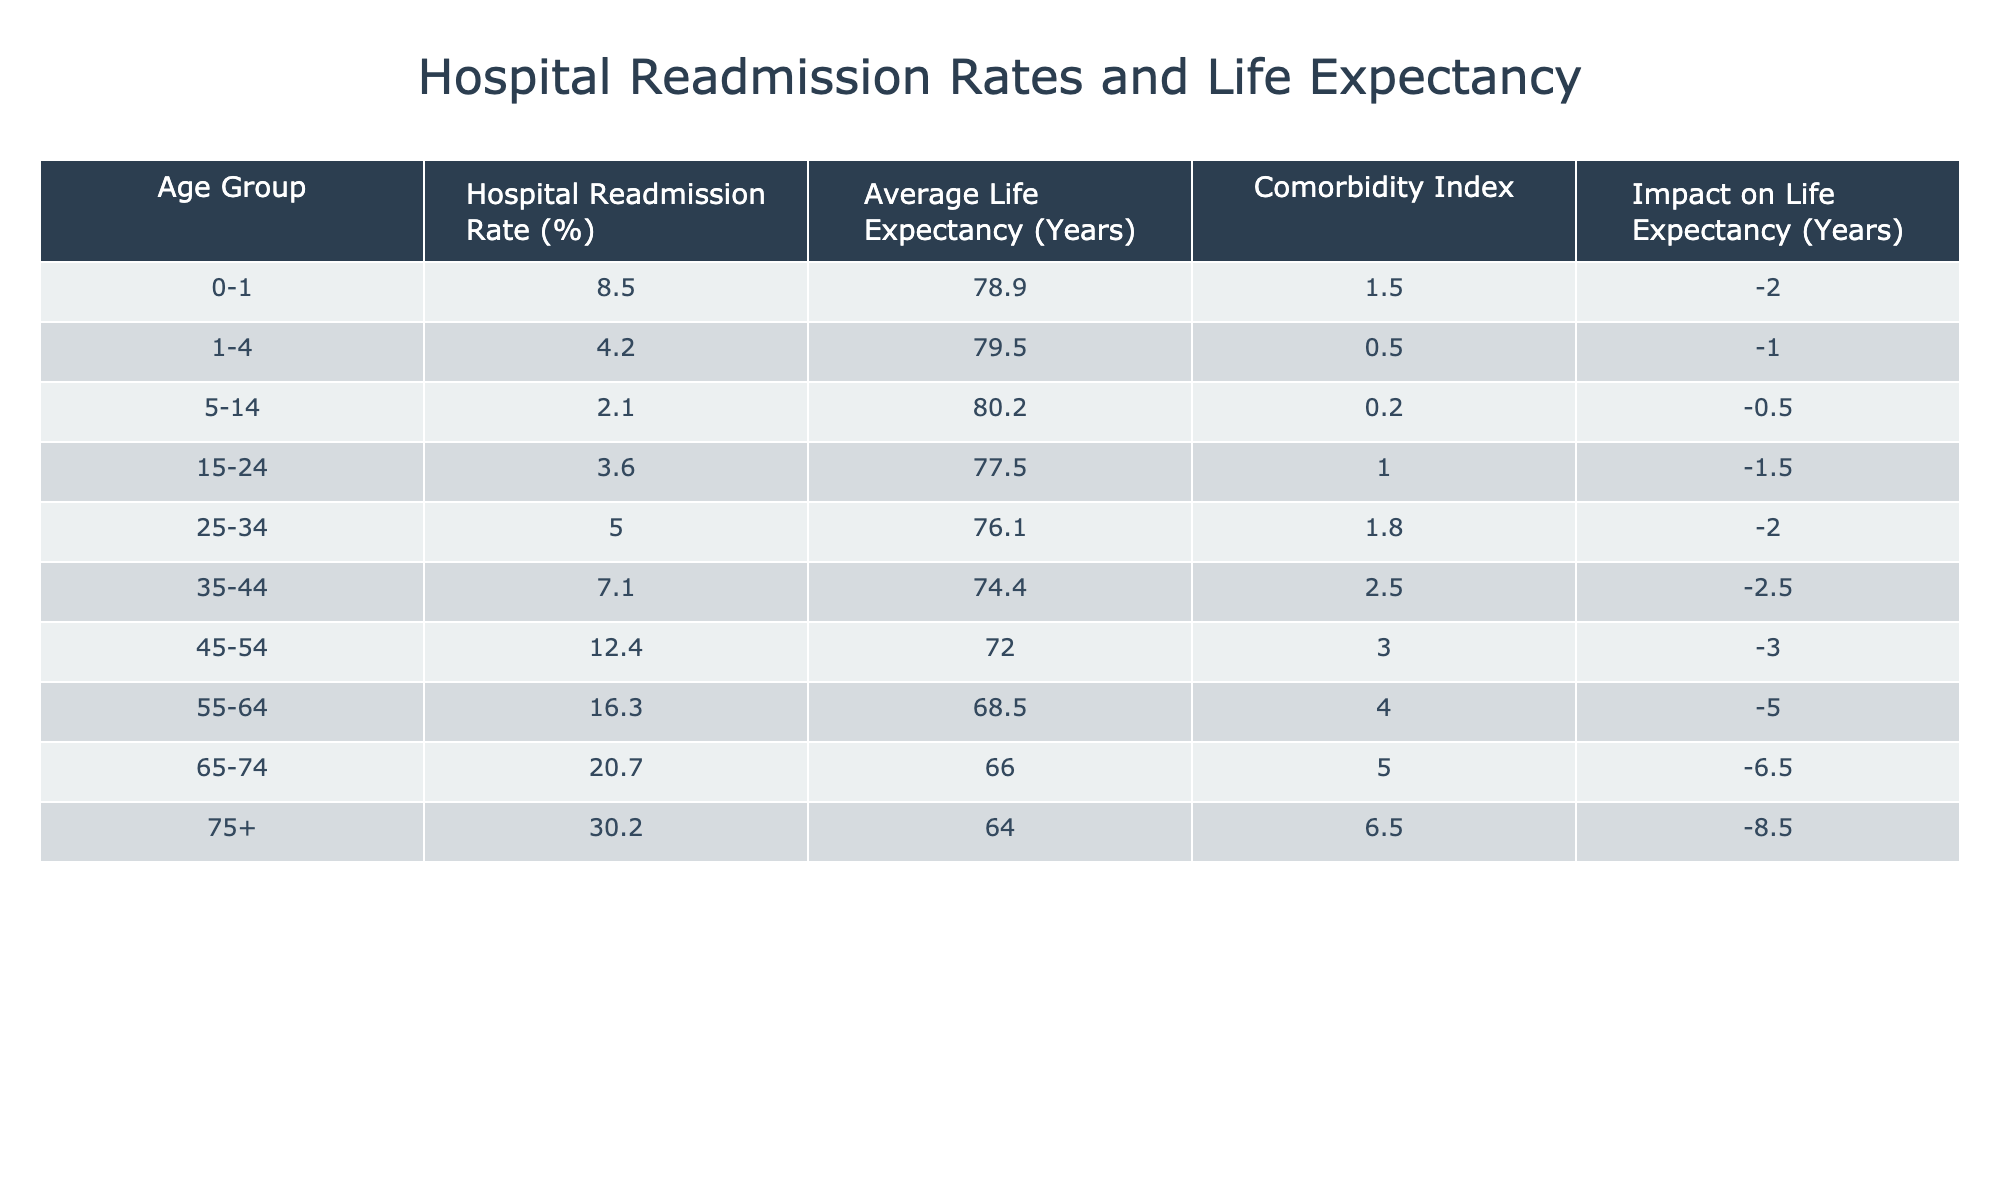What is the hospital readmission rate for the age group 35-44? The table shows that the hospital readmission rate for the age group 35-44 is 7.1%.
Answer: 7.1% Which age group has the highest impact on life expectancy? By checking the "Impact on Life Expectancy" column, the age group 75+ has the highest impact with a decrease of 8.5 years.
Answer: 75+ What is the average life expectancy for the age group 55-64? The table indicates that the average life expectancy for the age group 55-64 is 68.5 years.
Answer: 68.5 What is the difference in average life expectancy between age groups 0-1 and 75+? The average life expectancy for age group 0-1 is 78.9 years, while for 75+ it is 64.0 years. The difference is 78.9 - 64.0 = 14.9 years.
Answer: 14.9 Is it true that the comorbidity index increases with age? Reviewing the "Comorbidity Index" column, we see the index increases with each subsequent age group from 0.5 for 1-4 years to 6.5 for 75+, confirming that the statement is true.
Answer: Yes What is the average hospital readmission rate for the age groups 15-24 and 25-34? The hospital readmission rates for 15-24 is 3.6% and for 25-34 is 5.0%. Adding these gives 3.6 + 5.0 = 8.6%, and dividing by 2 for the average gives 8.6 / 2 = 4.3%.
Answer: 4.3% Which age group has the lowest hospital readmission rate? Looking through the "Hospital Readmission Rate" column, the age group 5-14 has the lowest rate at 2.1%.
Answer: 5-14 How many years does the hospital readmission impact reduce life expectancy for the age group 65-74? The table states that for the age group 65-74, the impact on life expectancy is -6.5 years. Thus, it reduces life expectancy by 6.5 years.
Answer: 6.5 What is the average comorbidity index for all age groups? The comorbidity index values are 1.5, 0.5, 0.2, 1.0, 1.8, 2.5, 3.0, 4.0, 5.0, and 6.5. Summing these gives 26.5, and dividing by 10 (the number of age groups) gives an average of 2.65.
Answer: 2.65 